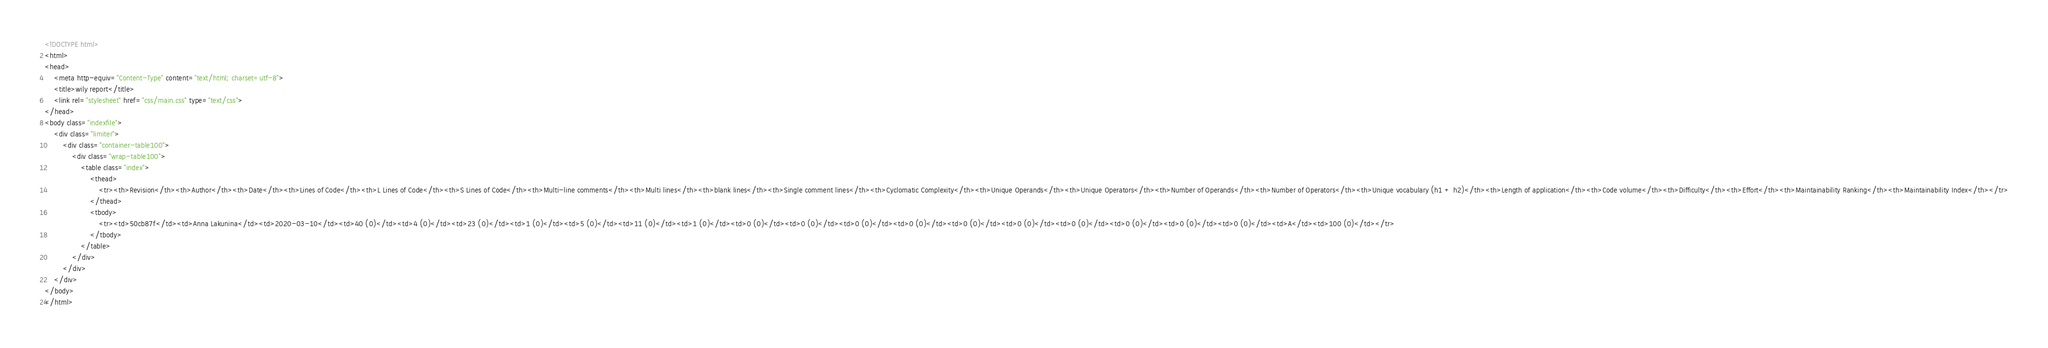<code> <loc_0><loc_0><loc_500><loc_500><_HTML_><!DOCTYPE html>
<html>
<head>
    <meta http-equiv="Content-Type" content="text/html; charset=utf-8">
    <title>wily report</title>
    <link rel="stylesheet" href="css/main.css" type="text/css">
</head>
<body class="indexfile">
    <div class="limiter">
		<div class="container-table100">
			<div class="wrap-table100">
                <table class="index">
                    <thead>
                        <tr><th>Revision</th><th>Author</th><th>Date</th><th>Lines of Code</th><th>L Lines of Code</th><th>S Lines of Code</th><th>Multi-line comments</th><th>Multi lines</th><th>blank lines</th><th>Single comment lines</th><th>Cyclomatic Complexity</th><th>Unique Operands</th><th>Unique Operators</th><th>Number of Operands</th><th>Number of Operators</th><th>Unique vocabulary (h1 + h2)</th><th>Length of application</th><th>Code volume</th><th>Difficulty</th><th>Effort</th><th>Maintainability Ranking</th><th>Maintainability Index</th></tr>
                    </thead>
                    <tbody>
                        <tr><td>50cb87f</td><td>Anna Lakunina</td><td>2020-03-10</td><td>40 (0)</td><td>4 (0)</td><td>23 (0)</td><td>1 (0)</td><td>5 (0)</td><td>11 (0)</td><td>1 (0)</td><td>0 (0)</td><td>0 (0)</td><td>0 (0)</td><td>0 (0)</td><td>0 (0)</td><td>0 (0)</td><td>0 (0)</td><td>0 (0)</td><td>0 (0)</td><td>0 (0)</td><td>A</td><td>100 (0)</td></tr>
                    </tbody>
                </table>
            </div>
        </div>
    </div>
</body>
</html></code> 